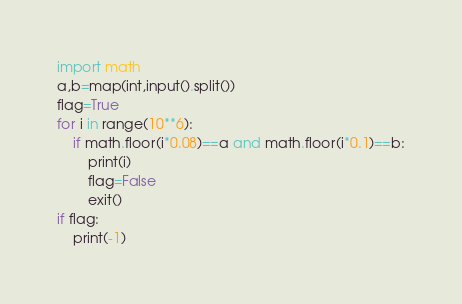Convert code to text. <code><loc_0><loc_0><loc_500><loc_500><_Python_>import math
a,b=map(int,input().split())
flag=True
for i in range(10**6):
    if math.floor(i*0.08)==a and math.floor(i*0.1)==b:
        print(i)
        flag=False
        exit()
if flag:
    print(-1)</code> 